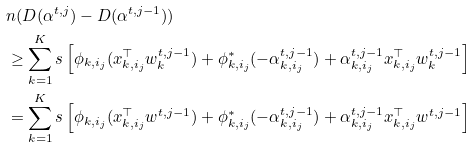Convert formula to latex. <formula><loc_0><loc_0><loc_500><loc_500>& n ( D ( \alpha ^ { t , j } ) - D ( \alpha ^ { t , j - 1 } ) ) \\ & \geq \sum _ { k = 1 } ^ { K } s \left [ \phi _ { k , i _ { j } } ( x _ { k , i _ { j } } ^ { \top } w _ { k } ^ { t , j - 1 } ) + \phi ^ { * } _ { k , i _ { j } } ( - \alpha ^ { t , j - 1 } _ { k , i _ { j } } ) + \alpha _ { k , i _ { j } } ^ { t , j - 1 } x _ { k , i _ { j } } ^ { \top } w ^ { t , j - 1 } _ { k } \right ] \\ & = \sum _ { k = 1 } ^ { K } s \left [ \phi _ { k , i _ { j } } ( x _ { k , i _ { j } } ^ { \top } w ^ { t , j - 1 } ) + \phi ^ { * } _ { k , i _ { j } } ( - \alpha ^ { t , j - 1 } _ { k , i _ { j } } ) + \alpha _ { k , i _ { j } } ^ { t , j - 1 } x _ { k , i _ { j } } ^ { \top } w ^ { t , j - 1 } \right ]</formula> 